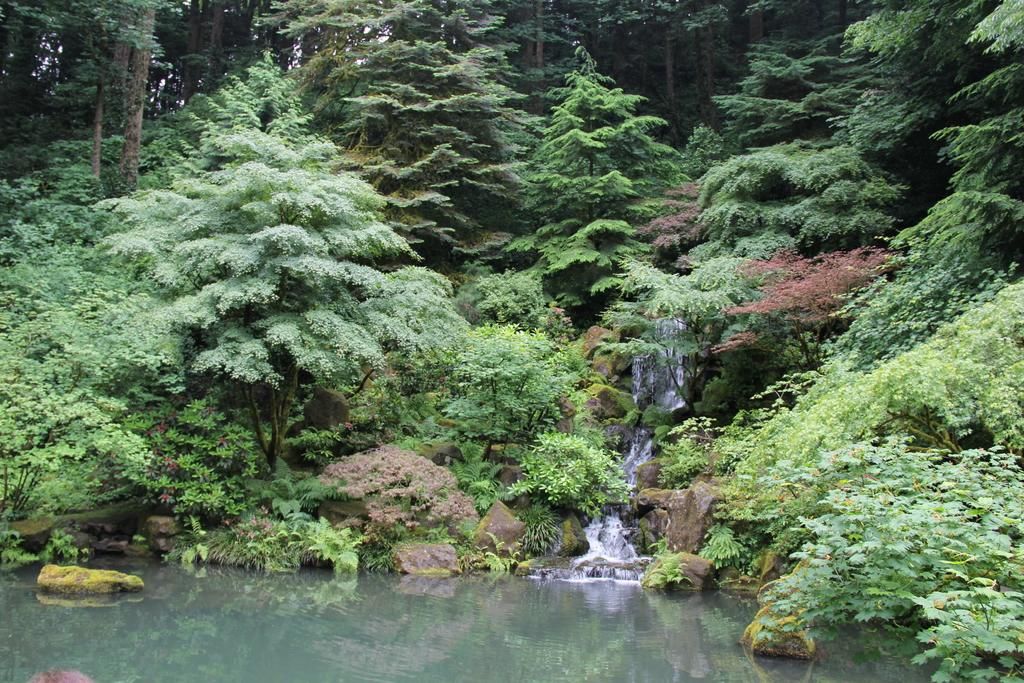What natural feature is the main subject of the image? There is a waterfall in the image. What can be seen in the water near the waterfall? There are rocks in the water in the image. What type of vegetation covers the ground in the image? The ground is covered with grass. What other types of vegetation are present in the image? Plants and trees are visible in the image. Can you describe the behavior of the sponge in the image? There is no sponge present in the image, so it is not possible to describe its behavior. 